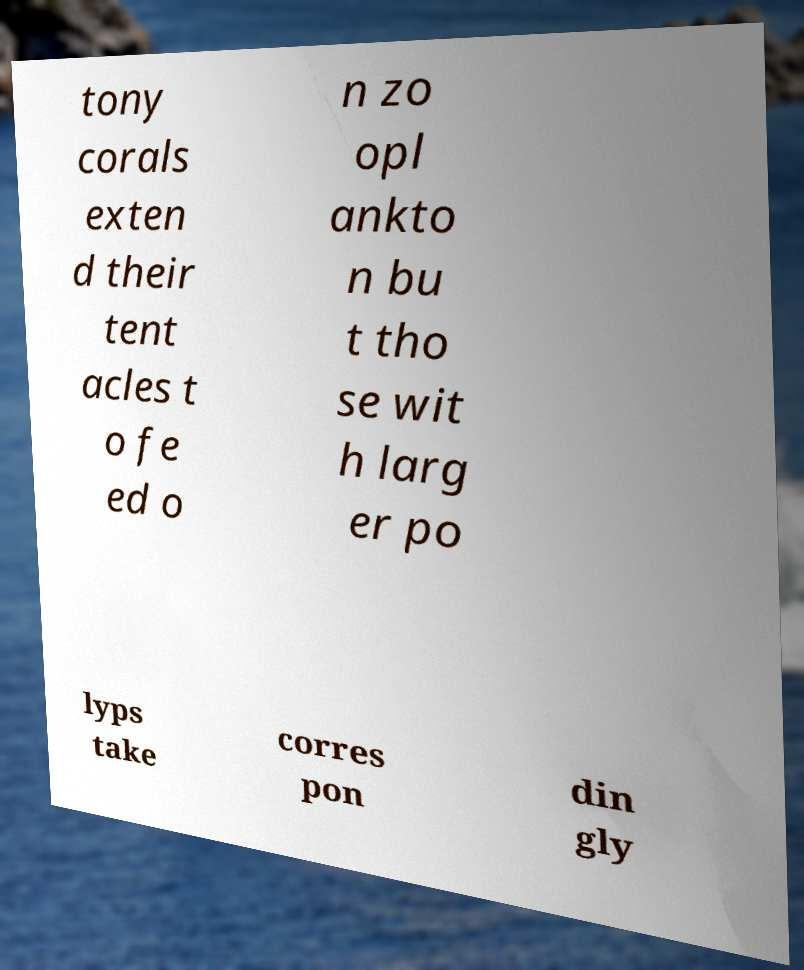Please identify and transcribe the text found in this image. tony corals exten d their tent acles t o fe ed o n zo opl ankto n bu t tho se wit h larg er po lyps take corres pon din gly 